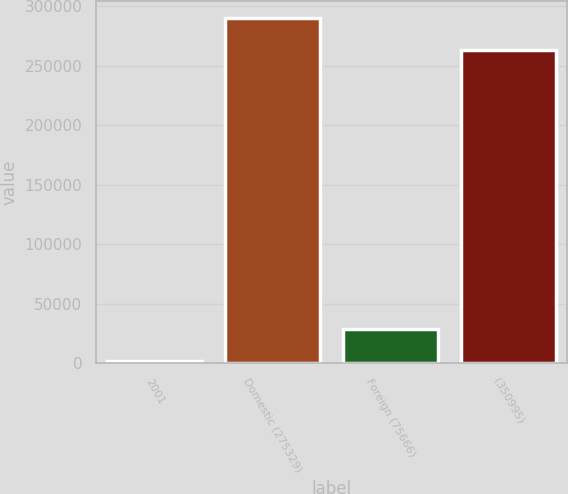<chart> <loc_0><loc_0><loc_500><loc_500><bar_chart><fcel>2001<fcel>Domestic (275329)<fcel>Foreign (75666)<fcel>(350995)<nl><fcel>2002<fcel>289643<fcel>28902.4<fcel>262743<nl></chart> 